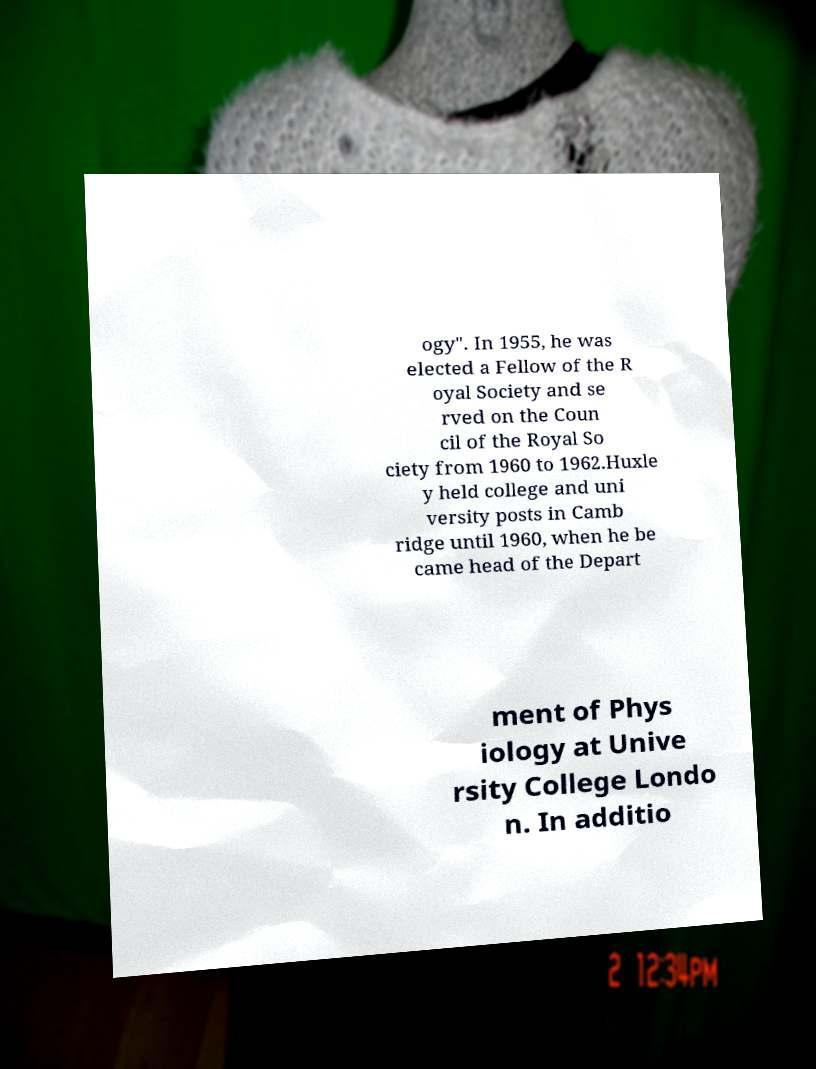What messages or text are displayed in this image? I need them in a readable, typed format. ogy". In 1955, he was elected a Fellow of the R oyal Society and se rved on the Coun cil of the Royal So ciety from 1960 to 1962.Huxle y held college and uni versity posts in Camb ridge until 1960, when he be came head of the Depart ment of Phys iology at Unive rsity College Londo n. In additio 